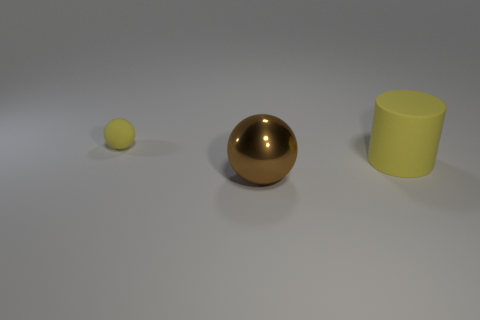Is there any other thing that is the same size as the matte ball?
Offer a very short reply. No. Is the yellow object that is in front of the tiny yellow sphere made of the same material as the thing left of the brown object?
Your response must be concise. Yes. What is the shape of the other object that is the same color as the tiny thing?
Give a very brief answer. Cylinder. How many tiny balls are made of the same material as the large yellow object?
Keep it short and to the point. 1. What is the color of the tiny object?
Offer a terse response. Yellow. Do the object to the left of the shiny thing and the big thing that is in front of the big cylinder have the same shape?
Make the answer very short. Yes. What is the color of the object that is to the left of the large shiny object?
Provide a short and direct response. Yellow. Is the number of yellow cylinders that are left of the tiny object less than the number of things behind the large shiny ball?
Make the answer very short. Yes. How many other objects are there of the same material as the large yellow cylinder?
Ensure brevity in your answer.  1. Are the big yellow cylinder and the large brown thing made of the same material?
Your answer should be very brief. No. 